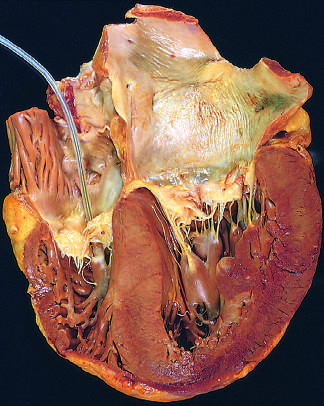where is the atrium shown?
Answer the question using a single word or phrase. On the right in this four-chamber view of the heart 